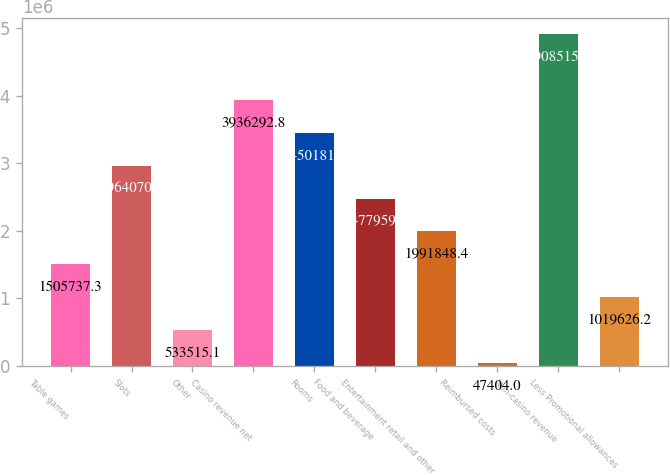Convert chart to OTSL. <chart><loc_0><loc_0><loc_500><loc_500><bar_chart><fcel>Table games<fcel>Slots<fcel>Other<fcel>Casino revenue net<fcel>Rooms<fcel>Food and beverage<fcel>Entertainment retail and other<fcel>Reimbursed costs<fcel>Non-casino revenue<fcel>Less Promotional allowances<nl><fcel>1.50574e+06<fcel>2.96407e+06<fcel>533515<fcel>3.93629e+06<fcel>3.45018e+06<fcel>2.47796e+06<fcel>1.99185e+06<fcel>47404<fcel>4.90852e+06<fcel>1.01963e+06<nl></chart> 